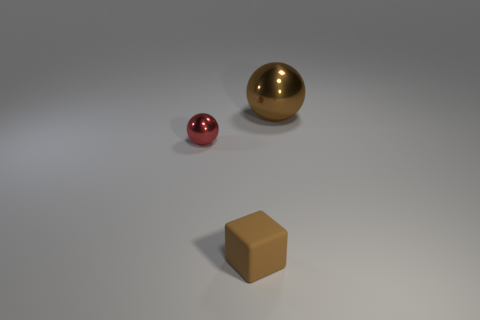Are there any cyan things of the same size as the brown metal thing?
Make the answer very short. No. Do the shiny sphere that is on the right side of the brown rubber cube and the rubber cube have the same color?
Offer a terse response. Yes. How many brown objects are tiny rubber things or spheres?
Provide a succinct answer. 2. What number of tiny matte blocks are the same color as the big ball?
Ensure brevity in your answer.  1. Do the big sphere and the brown block have the same material?
Provide a succinct answer. No. What number of tiny objects are on the left side of the thing in front of the tiny red ball?
Offer a very short reply. 1. Is the brown block the same size as the red ball?
Keep it short and to the point. Yes. How many small red things are the same material as the brown sphere?
Offer a terse response. 1. There is another red object that is the same shape as the large metal thing; what size is it?
Provide a succinct answer. Small. There is a brown thing that is behind the small red shiny thing; is it the same shape as the red shiny object?
Your answer should be very brief. Yes. 